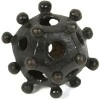What could this object be used to teach? This object is typically used as a visual aid in science education, particularly to teach about the structures of molecules, atoms, and their spatial arrangements in chemistry or biology. 